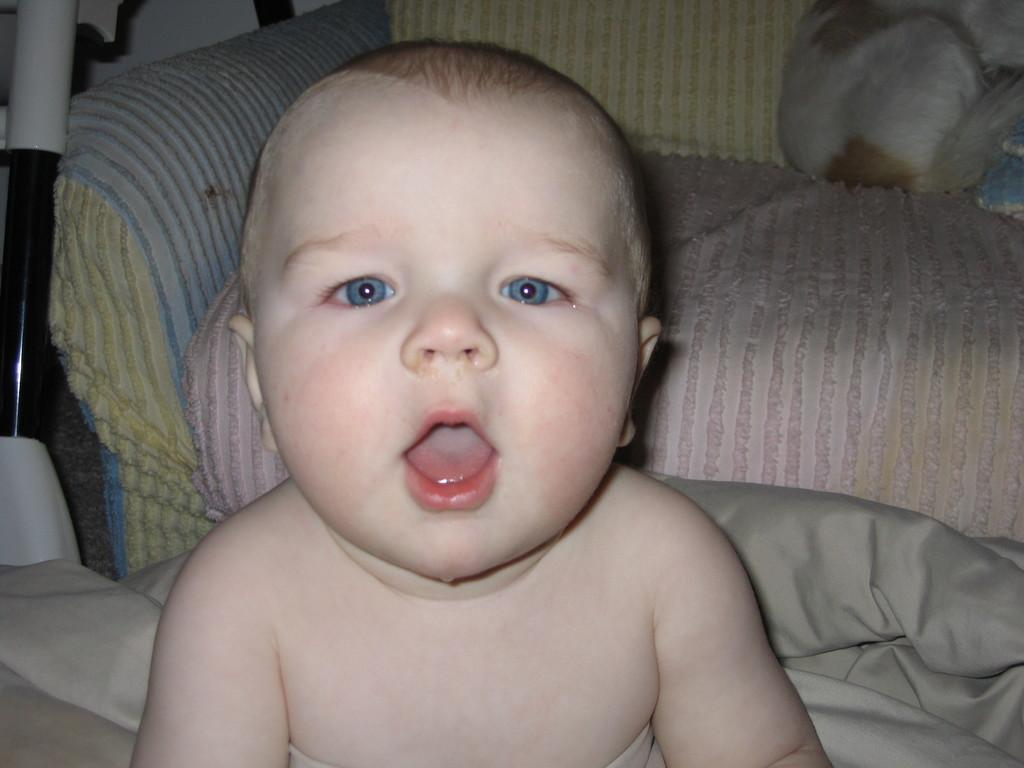What is the main subject of the picture? The main subject of the picture is a baby. What type of furniture is in the picture? There is a couch in the picture. Are there any other objects present in the picture besides the baby and couch? Yes, there are other objects present in the picture. What sign is the baby holding in the picture? There is no sign present in the image; the baby is not holding anything. What type of test is the baby taking in the picture? There is no test present in the image; the baby is simply depicted in the scene. 